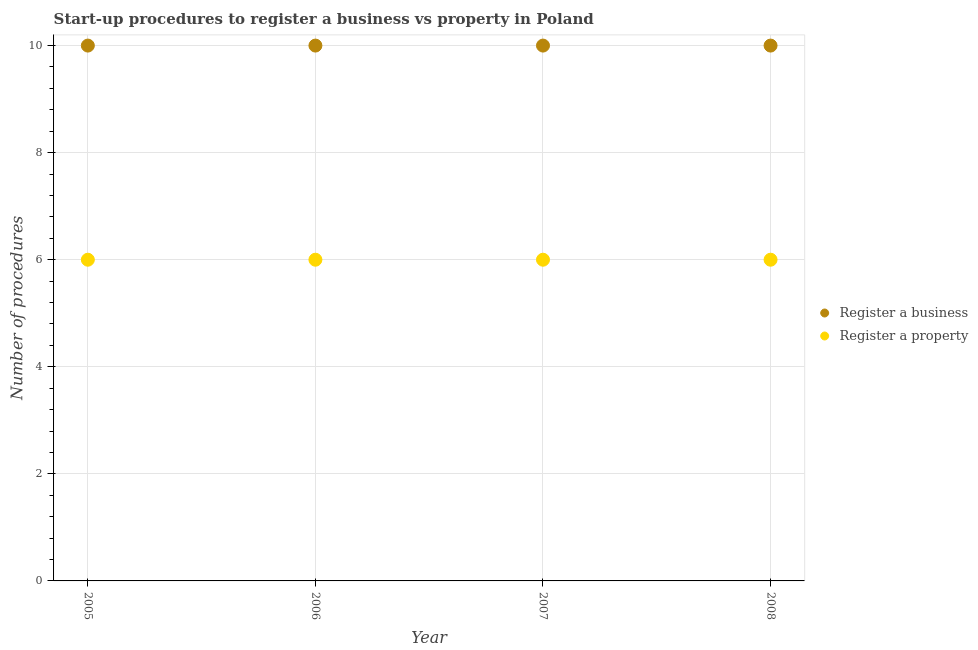What is the number of procedures to register a business in 2005?
Keep it short and to the point. 10. Across all years, what is the maximum number of procedures to register a business?
Your response must be concise. 10. Across all years, what is the minimum number of procedures to register a property?
Ensure brevity in your answer.  6. What is the total number of procedures to register a business in the graph?
Offer a very short reply. 40. What is the difference between the number of procedures to register a business in 2005 and that in 2007?
Ensure brevity in your answer.  0. What is the difference between the number of procedures to register a business in 2007 and the number of procedures to register a property in 2008?
Your response must be concise. 4. In the year 2008, what is the difference between the number of procedures to register a business and number of procedures to register a property?
Offer a very short reply. 4. Is the number of procedures to register a property in 2005 less than that in 2008?
Ensure brevity in your answer.  No. In how many years, is the number of procedures to register a property greater than the average number of procedures to register a property taken over all years?
Give a very brief answer. 0. Is the number of procedures to register a property strictly greater than the number of procedures to register a business over the years?
Offer a terse response. No. Is the number of procedures to register a business strictly less than the number of procedures to register a property over the years?
Offer a very short reply. No. How many dotlines are there?
Make the answer very short. 2. What is the difference between two consecutive major ticks on the Y-axis?
Provide a succinct answer. 2. Are the values on the major ticks of Y-axis written in scientific E-notation?
Keep it short and to the point. No. Does the graph contain any zero values?
Ensure brevity in your answer.  No. Does the graph contain grids?
Offer a very short reply. Yes. Where does the legend appear in the graph?
Provide a short and direct response. Center right. How are the legend labels stacked?
Ensure brevity in your answer.  Vertical. What is the title of the graph?
Make the answer very short. Start-up procedures to register a business vs property in Poland. Does "Goods" appear as one of the legend labels in the graph?
Keep it short and to the point. No. What is the label or title of the X-axis?
Give a very brief answer. Year. What is the label or title of the Y-axis?
Your answer should be compact. Number of procedures. What is the Number of procedures of Register a business in 2005?
Your response must be concise. 10. What is the Number of procedures in Register a property in 2005?
Provide a succinct answer. 6. What is the Number of procedures in Register a business in 2006?
Provide a short and direct response. 10. What is the Number of procedures of Register a property in 2006?
Your answer should be compact. 6. What is the Number of procedures of Register a property in 2007?
Offer a very short reply. 6. What is the Number of procedures of Register a property in 2008?
Your answer should be compact. 6. Across all years, what is the maximum Number of procedures in Register a property?
Offer a very short reply. 6. Across all years, what is the minimum Number of procedures of Register a business?
Your response must be concise. 10. What is the total Number of procedures in Register a business in the graph?
Your response must be concise. 40. What is the difference between the Number of procedures in Register a business in 2005 and that in 2006?
Offer a very short reply. 0. What is the difference between the Number of procedures of Register a business in 2005 and that in 2007?
Ensure brevity in your answer.  0. What is the difference between the Number of procedures in Register a property in 2005 and that in 2008?
Offer a terse response. 0. What is the difference between the Number of procedures of Register a business in 2006 and that in 2008?
Keep it short and to the point. 0. What is the difference between the Number of procedures of Register a property in 2006 and that in 2008?
Make the answer very short. 0. What is the difference between the Number of procedures of Register a property in 2007 and that in 2008?
Make the answer very short. 0. What is the difference between the Number of procedures of Register a business in 2005 and the Number of procedures of Register a property in 2008?
Ensure brevity in your answer.  4. What is the average Number of procedures of Register a business per year?
Provide a succinct answer. 10. In the year 2007, what is the difference between the Number of procedures in Register a business and Number of procedures in Register a property?
Your response must be concise. 4. In the year 2008, what is the difference between the Number of procedures in Register a business and Number of procedures in Register a property?
Ensure brevity in your answer.  4. What is the ratio of the Number of procedures in Register a business in 2005 to that in 2006?
Offer a terse response. 1. What is the ratio of the Number of procedures in Register a business in 2005 to that in 2007?
Keep it short and to the point. 1. What is the ratio of the Number of procedures in Register a business in 2005 to that in 2008?
Your answer should be very brief. 1. What is the ratio of the Number of procedures of Register a business in 2006 to that in 2007?
Provide a short and direct response. 1. What is the ratio of the Number of procedures in Register a property in 2006 to that in 2007?
Offer a terse response. 1. What is the ratio of the Number of procedures of Register a business in 2007 to that in 2008?
Make the answer very short. 1. What is the ratio of the Number of procedures of Register a property in 2007 to that in 2008?
Offer a terse response. 1. What is the difference between the highest and the second highest Number of procedures in Register a property?
Give a very brief answer. 0. What is the difference between the highest and the lowest Number of procedures of Register a property?
Offer a very short reply. 0. 